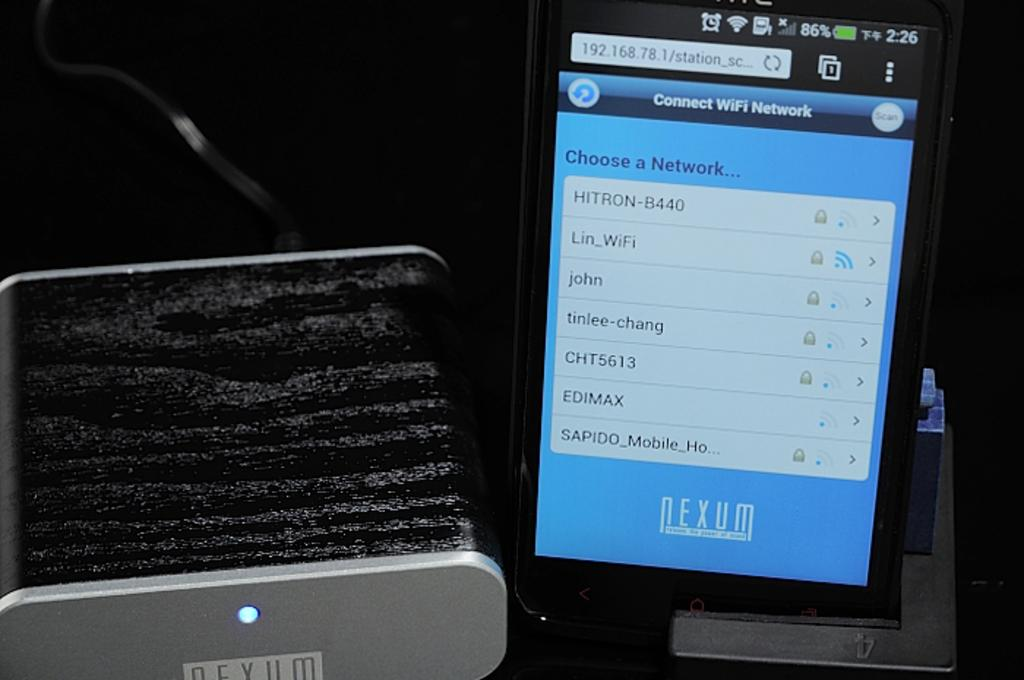<image>
Share a concise interpretation of the image provided. Phone screen that says "Connect Wifi Network" on it. 